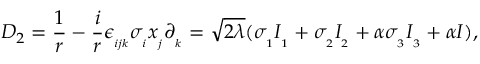Convert formula to latex. <formula><loc_0><loc_0><loc_500><loc_500>D _ { 2 } = \frac { 1 } { r } - \frac { i } { r } \epsilon _ { _ { i j k } } \sigma _ { _ { i } } x _ { _ { j } } \partial _ { _ { k } } = \sqrt { 2 \lambda } ( \sigma _ { _ { 1 } } I _ { _ { 1 } } + \sigma _ { _ { 2 } } I _ { _ { 2 } } + \alpha \sigma _ { _ { 3 } } I _ { _ { 3 } } + \alpha I ) ,</formula> 